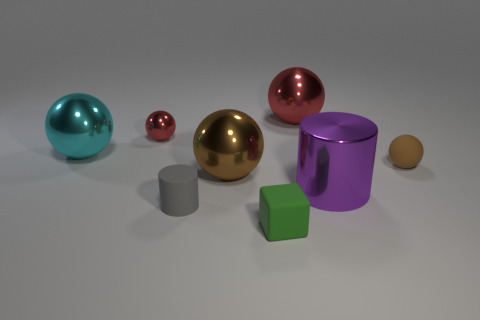What number of big objects are either brown metal objects or metal cylinders?
Provide a succinct answer. 2. Is there a large brown metal thing that is behind the red sphere on the left side of the rubber block?
Your answer should be very brief. No. Are there any tiny gray cylinders?
Keep it short and to the point. Yes. There is a cylinder that is right of the large sphere that is in front of the cyan metallic thing; what is its color?
Keep it short and to the point. Purple. What is the material of the other big object that is the same shape as the gray object?
Make the answer very short. Metal. What number of spheres are the same size as the green matte thing?
Your answer should be compact. 2. What is the size of the cube that is the same material as the small brown ball?
Ensure brevity in your answer.  Small. What number of gray things are the same shape as the tiny green object?
Give a very brief answer. 0. How many big green metal things are there?
Provide a short and direct response. 0. There is a tiny gray object in front of the purple cylinder; is it the same shape as the big red object?
Provide a short and direct response. No. 